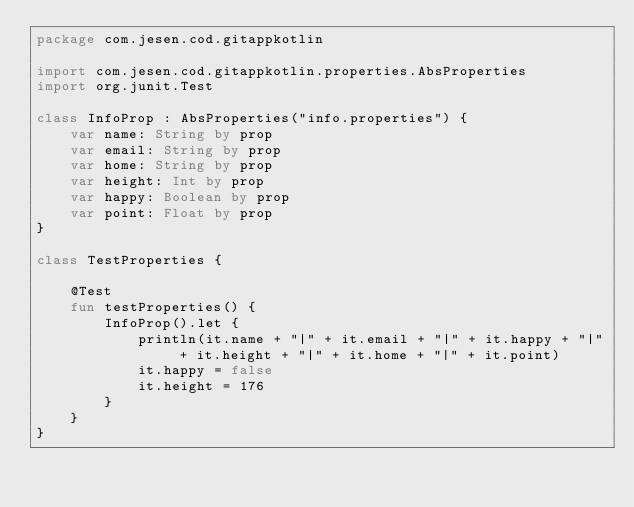Convert code to text. <code><loc_0><loc_0><loc_500><loc_500><_Kotlin_>package com.jesen.cod.gitappkotlin

import com.jesen.cod.gitappkotlin.properties.AbsProperties
import org.junit.Test

class InfoProp : AbsProperties("info.properties") {
    var name: String by prop
    var email: String by prop
    var home: String by prop
    var height: Int by prop
    var happy: Boolean by prop
    var point: Float by prop
}

class TestProperties {

    @Test
    fun testProperties() {
        InfoProp().let {
            println(it.name + "|" + it.email + "|" + it.happy + "|" + it.height + "|" + it.home + "|" + it.point)
            it.happy = false
            it.height = 176
        }
    }
}</code> 